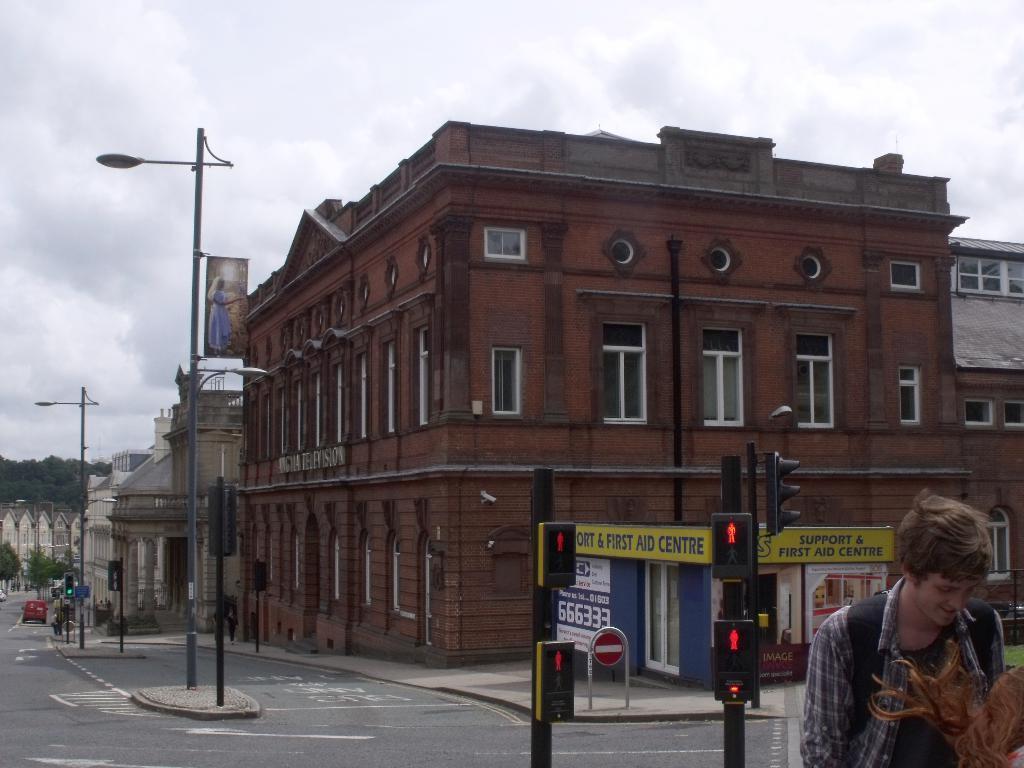Describe this image in one or two sentences. This is the picture of a city. On the right side of the image there are two persons and there are traffic signal poles. At the back there are buildings, poles and trees and there is a vehicle on the road. At the top there are clouds. At the bottom there is a road. 